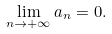Convert formula to latex. <formula><loc_0><loc_0><loc_500><loc_500>\lim _ { n \to + \infty } a _ { n } = 0 .</formula> 